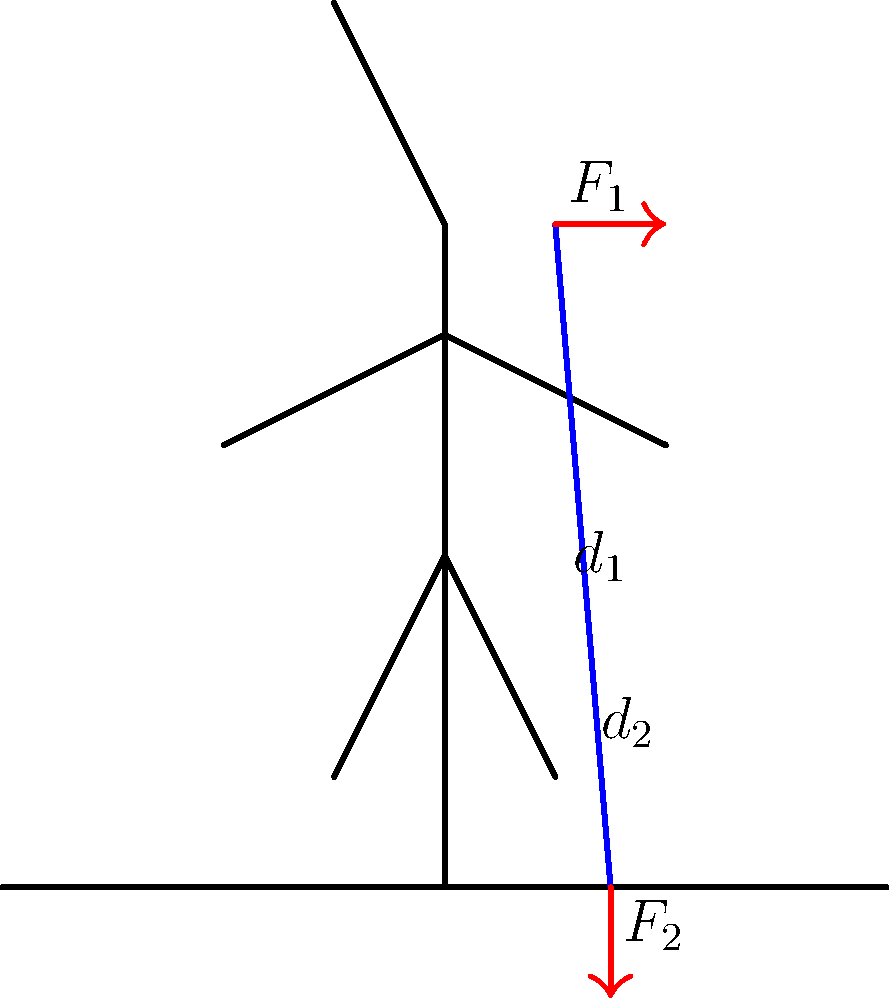As part of your NGO's health outreach program in Southeast Asia, you're explaining the biomechanics of using a cane to local healthcare workers. Using the diagram, calculate the force $F_2$ exerted by the ground on the cane if a person applies a downward force $F_1$ of 200 N at the top of the cane. The distance from the top of the cane to the ground ($d_1 + d_2$) is 1.2 m, and the distance from the bottom of the cane to the center of rotation ($d_2$) is 0.3 m. To solve this problem, we'll use the principle of moments, which states that for an object in equilibrium, the sum of clockwise moments equals the sum of counterclockwise moments about any point.

Step 1: Identify the relevant information
- $F_1 = 200$ N (downward force applied by the person)
- Total length of the cane = $d_1 + d_2 = 1.2$ m
- $d_2 = 0.3$ m (distance from ground to center of rotation)
- $d_1 = 1.2 - 0.3 = 0.9$ m (distance from top of cane to center of rotation)

Step 2: Set up the moment equation
Let's take moments about the point where the cane touches the ground. The clockwise moment is caused by $F_1$, and the counterclockwise moment is caused by $F_2$.

$F_1 \times (d_1 + d_2) = F_2 \times d_2$

Step 3: Substitute known values
$200 \text{ N} \times 1.2 \text{ m} = F_2 \times 0.3 \text{ m}$

Step 4: Solve for $F_2$
$240 \text{ N⋅m} = F_2 \times 0.3 \text{ m}$
$F_2 = \frac{240 \text{ N⋅m}}{0.3 \text{ m}} = 800 \text{ N}$

Therefore, the force $F_2$ exerted by the ground on the cane is 800 N.
Answer: $F_2 = 800 \text{ N}$ 